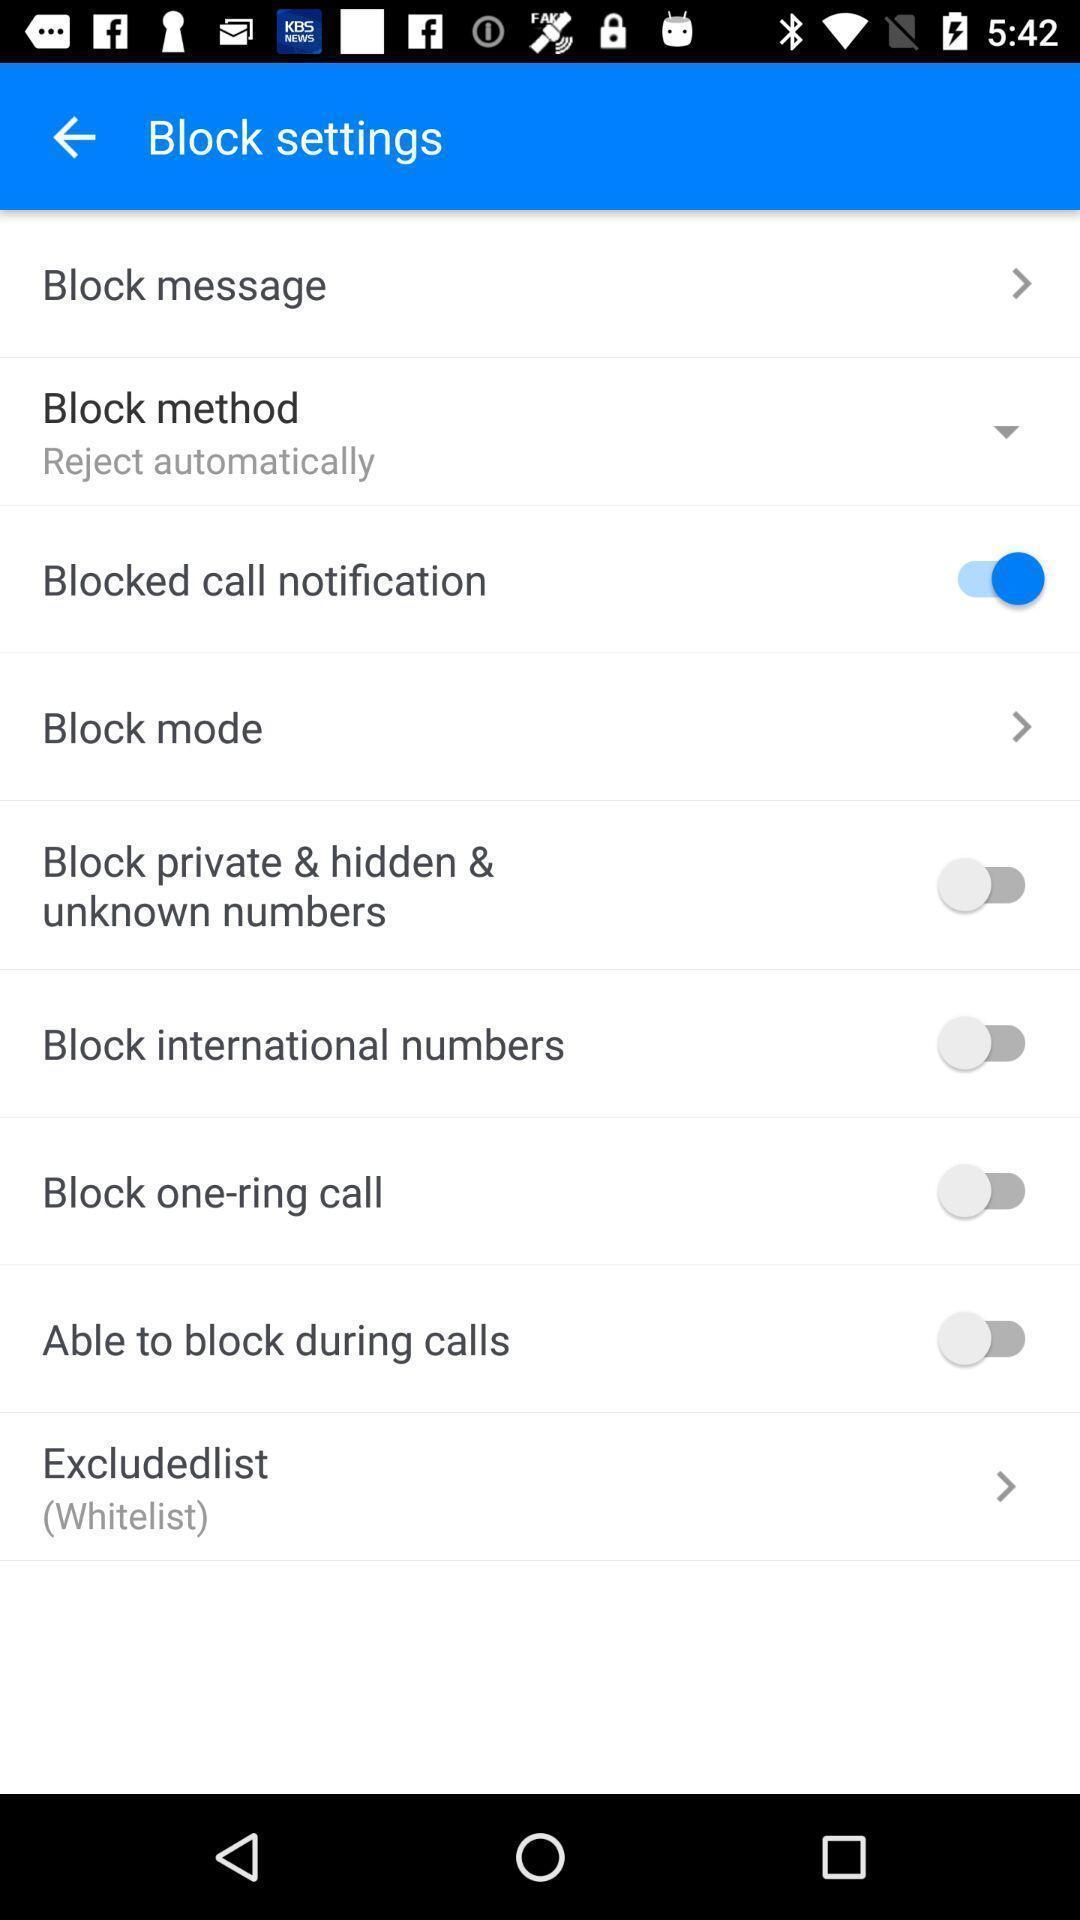Give me a summary of this screen capture. Settings page in a calling app. 